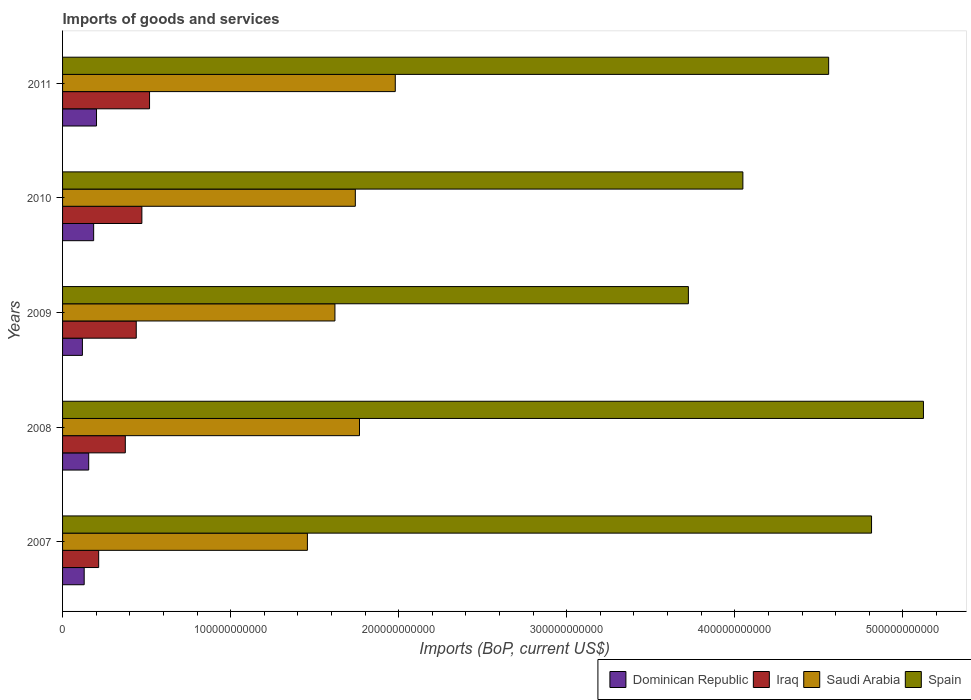How many different coloured bars are there?
Offer a terse response. 4. Are the number of bars per tick equal to the number of legend labels?
Make the answer very short. Yes. Are the number of bars on each tick of the Y-axis equal?
Your answer should be compact. Yes. How many bars are there on the 3rd tick from the top?
Ensure brevity in your answer.  4. How many bars are there on the 4th tick from the bottom?
Provide a succinct answer. 4. What is the amount spent on imports in Iraq in 2011?
Offer a very short reply. 5.18e+1. Across all years, what is the maximum amount spent on imports in Iraq?
Offer a terse response. 5.18e+1. Across all years, what is the minimum amount spent on imports in Dominican Republic?
Give a very brief answer. 1.18e+1. In which year was the amount spent on imports in Dominican Republic maximum?
Keep it short and to the point. 2011. In which year was the amount spent on imports in Iraq minimum?
Provide a short and direct response. 2007. What is the total amount spent on imports in Saudi Arabia in the graph?
Offer a terse response. 8.57e+11. What is the difference between the amount spent on imports in Iraq in 2007 and that in 2009?
Make the answer very short. -2.24e+1. What is the difference between the amount spent on imports in Saudi Arabia in 2008 and the amount spent on imports in Dominican Republic in 2007?
Offer a very short reply. 1.64e+11. What is the average amount spent on imports in Dominican Republic per year?
Give a very brief answer. 1.58e+1. In the year 2009, what is the difference between the amount spent on imports in Iraq and amount spent on imports in Spain?
Your answer should be very brief. -3.29e+11. In how many years, is the amount spent on imports in Iraq greater than 160000000000 US$?
Offer a terse response. 0. What is the ratio of the amount spent on imports in Iraq in 2007 to that in 2010?
Make the answer very short. 0.46. Is the amount spent on imports in Saudi Arabia in 2010 less than that in 2011?
Your response must be concise. Yes. Is the difference between the amount spent on imports in Iraq in 2007 and 2009 greater than the difference between the amount spent on imports in Spain in 2007 and 2009?
Ensure brevity in your answer.  No. What is the difference between the highest and the second highest amount spent on imports in Saudi Arabia?
Keep it short and to the point. 2.13e+1. What is the difference between the highest and the lowest amount spent on imports in Saudi Arabia?
Your answer should be compact. 5.23e+1. Is the sum of the amount spent on imports in Saudi Arabia in 2007 and 2008 greater than the maximum amount spent on imports in Spain across all years?
Your answer should be very brief. No. Is it the case that in every year, the sum of the amount spent on imports in Dominican Republic and amount spent on imports in Iraq is greater than the sum of amount spent on imports in Spain and amount spent on imports in Saudi Arabia?
Offer a very short reply. No. What does the 3rd bar from the top in 2011 represents?
Ensure brevity in your answer.  Iraq. What does the 2nd bar from the bottom in 2009 represents?
Your answer should be very brief. Iraq. What is the difference between two consecutive major ticks on the X-axis?
Offer a terse response. 1.00e+11. Does the graph contain grids?
Give a very brief answer. No. How are the legend labels stacked?
Ensure brevity in your answer.  Horizontal. What is the title of the graph?
Give a very brief answer. Imports of goods and services. Does "Senegal" appear as one of the legend labels in the graph?
Provide a short and direct response. No. What is the label or title of the X-axis?
Offer a terse response. Imports (BoP, current US$). What is the label or title of the Y-axis?
Keep it short and to the point. Years. What is the Imports (BoP, current US$) of Dominican Republic in 2007?
Your answer should be very brief. 1.29e+1. What is the Imports (BoP, current US$) in Iraq in 2007?
Provide a succinct answer. 2.15e+1. What is the Imports (BoP, current US$) in Saudi Arabia in 2007?
Keep it short and to the point. 1.46e+11. What is the Imports (BoP, current US$) in Spain in 2007?
Your answer should be very brief. 4.81e+11. What is the Imports (BoP, current US$) in Dominican Republic in 2008?
Make the answer very short. 1.56e+1. What is the Imports (BoP, current US$) of Iraq in 2008?
Offer a terse response. 3.73e+1. What is the Imports (BoP, current US$) of Saudi Arabia in 2008?
Keep it short and to the point. 1.77e+11. What is the Imports (BoP, current US$) of Spain in 2008?
Provide a short and direct response. 5.12e+11. What is the Imports (BoP, current US$) in Dominican Republic in 2009?
Offer a very short reply. 1.18e+1. What is the Imports (BoP, current US$) in Iraq in 2009?
Keep it short and to the point. 4.38e+1. What is the Imports (BoP, current US$) in Saudi Arabia in 2009?
Give a very brief answer. 1.62e+11. What is the Imports (BoP, current US$) in Spain in 2009?
Your answer should be compact. 3.72e+11. What is the Imports (BoP, current US$) of Dominican Republic in 2010?
Your answer should be very brief. 1.85e+1. What is the Imports (BoP, current US$) in Iraq in 2010?
Keep it short and to the point. 4.72e+1. What is the Imports (BoP, current US$) in Saudi Arabia in 2010?
Your response must be concise. 1.74e+11. What is the Imports (BoP, current US$) of Spain in 2010?
Your answer should be compact. 4.05e+11. What is the Imports (BoP, current US$) in Dominican Republic in 2011?
Offer a terse response. 2.02e+1. What is the Imports (BoP, current US$) in Iraq in 2011?
Provide a succinct answer. 5.18e+1. What is the Imports (BoP, current US$) in Saudi Arabia in 2011?
Ensure brevity in your answer.  1.98e+11. What is the Imports (BoP, current US$) of Spain in 2011?
Provide a short and direct response. 4.56e+11. Across all years, what is the maximum Imports (BoP, current US$) of Dominican Republic?
Your answer should be compact. 2.02e+1. Across all years, what is the maximum Imports (BoP, current US$) of Iraq?
Your response must be concise. 5.18e+1. Across all years, what is the maximum Imports (BoP, current US$) of Saudi Arabia?
Your answer should be very brief. 1.98e+11. Across all years, what is the maximum Imports (BoP, current US$) in Spain?
Make the answer very short. 5.12e+11. Across all years, what is the minimum Imports (BoP, current US$) in Dominican Republic?
Make the answer very short. 1.18e+1. Across all years, what is the minimum Imports (BoP, current US$) in Iraq?
Your answer should be very brief. 2.15e+1. Across all years, what is the minimum Imports (BoP, current US$) of Saudi Arabia?
Give a very brief answer. 1.46e+11. Across all years, what is the minimum Imports (BoP, current US$) in Spain?
Ensure brevity in your answer.  3.72e+11. What is the total Imports (BoP, current US$) in Dominican Republic in the graph?
Provide a succinct answer. 7.89e+1. What is the total Imports (BoP, current US$) in Iraq in the graph?
Keep it short and to the point. 2.02e+11. What is the total Imports (BoP, current US$) in Saudi Arabia in the graph?
Your answer should be compact. 8.57e+11. What is the total Imports (BoP, current US$) in Spain in the graph?
Provide a short and direct response. 2.23e+12. What is the difference between the Imports (BoP, current US$) of Dominican Republic in 2007 and that in 2008?
Provide a succinct answer. -2.68e+09. What is the difference between the Imports (BoP, current US$) of Iraq in 2007 and that in 2008?
Provide a short and direct response. -1.58e+1. What is the difference between the Imports (BoP, current US$) in Saudi Arabia in 2007 and that in 2008?
Provide a short and direct response. -3.10e+1. What is the difference between the Imports (BoP, current US$) in Spain in 2007 and that in 2008?
Ensure brevity in your answer.  -3.09e+1. What is the difference between the Imports (BoP, current US$) in Dominican Republic in 2007 and that in 2009?
Offer a very short reply. 1.07e+09. What is the difference between the Imports (BoP, current US$) of Iraq in 2007 and that in 2009?
Offer a terse response. -2.24e+1. What is the difference between the Imports (BoP, current US$) in Saudi Arabia in 2007 and that in 2009?
Offer a terse response. -1.64e+1. What is the difference between the Imports (BoP, current US$) in Spain in 2007 and that in 2009?
Your answer should be compact. 1.09e+11. What is the difference between the Imports (BoP, current US$) of Dominican Republic in 2007 and that in 2010?
Your response must be concise. -5.63e+09. What is the difference between the Imports (BoP, current US$) in Iraq in 2007 and that in 2010?
Your response must be concise. -2.57e+1. What is the difference between the Imports (BoP, current US$) in Saudi Arabia in 2007 and that in 2010?
Your response must be concise. -2.85e+1. What is the difference between the Imports (BoP, current US$) of Spain in 2007 and that in 2010?
Ensure brevity in your answer.  7.66e+1. What is the difference between the Imports (BoP, current US$) in Dominican Republic in 2007 and that in 2011?
Your answer should be very brief. -7.33e+09. What is the difference between the Imports (BoP, current US$) in Iraq in 2007 and that in 2011?
Your answer should be compact. -3.03e+1. What is the difference between the Imports (BoP, current US$) of Saudi Arabia in 2007 and that in 2011?
Ensure brevity in your answer.  -5.23e+1. What is the difference between the Imports (BoP, current US$) of Spain in 2007 and that in 2011?
Provide a short and direct response. 2.55e+1. What is the difference between the Imports (BoP, current US$) in Dominican Republic in 2008 and that in 2009?
Your answer should be compact. 3.75e+09. What is the difference between the Imports (BoP, current US$) of Iraq in 2008 and that in 2009?
Your answer should be very brief. -6.51e+09. What is the difference between the Imports (BoP, current US$) of Saudi Arabia in 2008 and that in 2009?
Ensure brevity in your answer.  1.46e+1. What is the difference between the Imports (BoP, current US$) in Spain in 2008 and that in 2009?
Provide a short and direct response. 1.40e+11. What is the difference between the Imports (BoP, current US$) of Dominican Republic in 2008 and that in 2010?
Offer a terse response. -2.94e+09. What is the difference between the Imports (BoP, current US$) of Iraq in 2008 and that in 2010?
Offer a terse response. -9.86e+09. What is the difference between the Imports (BoP, current US$) in Saudi Arabia in 2008 and that in 2010?
Ensure brevity in your answer.  2.48e+09. What is the difference between the Imports (BoP, current US$) in Spain in 2008 and that in 2010?
Make the answer very short. 1.07e+11. What is the difference between the Imports (BoP, current US$) in Dominican Republic in 2008 and that in 2011?
Give a very brief answer. -4.65e+09. What is the difference between the Imports (BoP, current US$) of Iraq in 2008 and that in 2011?
Keep it short and to the point. -1.44e+1. What is the difference between the Imports (BoP, current US$) in Saudi Arabia in 2008 and that in 2011?
Provide a succinct answer. -2.13e+1. What is the difference between the Imports (BoP, current US$) of Spain in 2008 and that in 2011?
Your response must be concise. 5.64e+1. What is the difference between the Imports (BoP, current US$) of Dominican Republic in 2009 and that in 2010?
Your answer should be compact. -6.69e+09. What is the difference between the Imports (BoP, current US$) of Iraq in 2009 and that in 2010?
Offer a very short reply. -3.34e+09. What is the difference between the Imports (BoP, current US$) in Saudi Arabia in 2009 and that in 2010?
Offer a very short reply. -1.21e+1. What is the difference between the Imports (BoP, current US$) of Spain in 2009 and that in 2010?
Your response must be concise. -3.24e+1. What is the difference between the Imports (BoP, current US$) in Dominican Republic in 2009 and that in 2011?
Your response must be concise. -8.40e+09. What is the difference between the Imports (BoP, current US$) in Iraq in 2009 and that in 2011?
Keep it short and to the point. -7.91e+09. What is the difference between the Imports (BoP, current US$) of Saudi Arabia in 2009 and that in 2011?
Provide a short and direct response. -3.59e+1. What is the difference between the Imports (BoP, current US$) of Spain in 2009 and that in 2011?
Make the answer very short. -8.35e+1. What is the difference between the Imports (BoP, current US$) in Dominican Republic in 2010 and that in 2011?
Offer a very short reply. -1.70e+09. What is the difference between the Imports (BoP, current US$) in Iraq in 2010 and that in 2011?
Ensure brevity in your answer.  -4.57e+09. What is the difference between the Imports (BoP, current US$) of Saudi Arabia in 2010 and that in 2011?
Your response must be concise. -2.38e+1. What is the difference between the Imports (BoP, current US$) of Spain in 2010 and that in 2011?
Offer a terse response. -5.10e+1. What is the difference between the Imports (BoP, current US$) in Dominican Republic in 2007 and the Imports (BoP, current US$) in Iraq in 2008?
Keep it short and to the point. -2.45e+1. What is the difference between the Imports (BoP, current US$) of Dominican Republic in 2007 and the Imports (BoP, current US$) of Saudi Arabia in 2008?
Ensure brevity in your answer.  -1.64e+11. What is the difference between the Imports (BoP, current US$) of Dominican Republic in 2007 and the Imports (BoP, current US$) of Spain in 2008?
Provide a short and direct response. -4.99e+11. What is the difference between the Imports (BoP, current US$) of Iraq in 2007 and the Imports (BoP, current US$) of Saudi Arabia in 2008?
Offer a very short reply. -1.55e+11. What is the difference between the Imports (BoP, current US$) in Iraq in 2007 and the Imports (BoP, current US$) in Spain in 2008?
Your answer should be compact. -4.91e+11. What is the difference between the Imports (BoP, current US$) in Saudi Arabia in 2007 and the Imports (BoP, current US$) in Spain in 2008?
Your response must be concise. -3.67e+11. What is the difference between the Imports (BoP, current US$) in Dominican Republic in 2007 and the Imports (BoP, current US$) in Iraq in 2009?
Keep it short and to the point. -3.10e+1. What is the difference between the Imports (BoP, current US$) in Dominican Republic in 2007 and the Imports (BoP, current US$) in Saudi Arabia in 2009?
Provide a short and direct response. -1.49e+11. What is the difference between the Imports (BoP, current US$) in Dominican Republic in 2007 and the Imports (BoP, current US$) in Spain in 2009?
Keep it short and to the point. -3.60e+11. What is the difference between the Imports (BoP, current US$) in Iraq in 2007 and the Imports (BoP, current US$) in Saudi Arabia in 2009?
Provide a short and direct response. -1.41e+11. What is the difference between the Imports (BoP, current US$) of Iraq in 2007 and the Imports (BoP, current US$) of Spain in 2009?
Ensure brevity in your answer.  -3.51e+11. What is the difference between the Imports (BoP, current US$) in Saudi Arabia in 2007 and the Imports (BoP, current US$) in Spain in 2009?
Your answer should be compact. -2.27e+11. What is the difference between the Imports (BoP, current US$) of Dominican Republic in 2007 and the Imports (BoP, current US$) of Iraq in 2010?
Keep it short and to the point. -3.43e+1. What is the difference between the Imports (BoP, current US$) in Dominican Republic in 2007 and the Imports (BoP, current US$) in Saudi Arabia in 2010?
Provide a succinct answer. -1.61e+11. What is the difference between the Imports (BoP, current US$) in Dominican Republic in 2007 and the Imports (BoP, current US$) in Spain in 2010?
Your answer should be compact. -3.92e+11. What is the difference between the Imports (BoP, current US$) in Iraq in 2007 and the Imports (BoP, current US$) in Saudi Arabia in 2010?
Your answer should be compact. -1.53e+11. What is the difference between the Imports (BoP, current US$) in Iraq in 2007 and the Imports (BoP, current US$) in Spain in 2010?
Your answer should be very brief. -3.83e+11. What is the difference between the Imports (BoP, current US$) of Saudi Arabia in 2007 and the Imports (BoP, current US$) of Spain in 2010?
Offer a terse response. -2.59e+11. What is the difference between the Imports (BoP, current US$) in Dominican Republic in 2007 and the Imports (BoP, current US$) in Iraq in 2011?
Offer a very short reply. -3.89e+1. What is the difference between the Imports (BoP, current US$) in Dominican Republic in 2007 and the Imports (BoP, current US$) in Saudi Arabia in 2011?
Ensure brevity in your answer.  -1.85e+11. What is the difference between the Imports (BoP, current US$) in Dominican Republic in 2007 and the Imports (BoP, current US$) in Spain in 2011?
Provide a short and direct response. -4.43e+11. What is the difference between the Imports (BoP, current US$) in Iraq in 2007 and the Imports (BoP, current US$) in Saudi Arabia in 2011?
Your answer should be compact. -1.76e+11. What is the difference between the Imports (BoP, current US$) in Iraq in 2007 and the Imports (BoP, current US$) in Spain in 2011?
Keep it short and to the point. -4.34e+11. What is the difference between the Imports (BoP, current US$) of Saudi Arabia in 2007 and the Imports (BoP, current US$) of Spain in 2011?
Provide a succinct answer. -3.10e+11. What is the difference between the Imports (BoP, current US$) of Dominican Republic in 2008 and the Imports (BoP, current US$) of Iraq in 2009?
Your response must be concise. -2.83e+1. What is the difference between the Imports (BoP, current US$) of Dominican Republic in 2008 and the Imports (BoP, current US$) of Saudi Arabia in 2009?
Provide a short and direct response. -1.47e+11. What is the difference between the Imports (BoP, current US$) of Dominican Republic in 2008 and the Imports (BoP, current US$) of Spain in 2009?
Your answer should be compact. -3.57e+11. What is the difference between the Imports (BoP, current US$) in Iraq in 2008 and the Imports (BoP, current US$) in Saudi Arabia in 2009?
Offer a very short reply. -1.25e+11. What is the difference between the Imports (BoP, current US$) in Iraq in 2008 and the Imports (BoP, current US$) in Spain in 2009?
Provide a succinct answer. -3.35e+11. What is the difference between the Imports (BoP, current US$) of Saudi Arabia in 2008 and the Imports (BoP, current US$) of Spain in 2009?
Your answer should be compact. -1.96e+11. What is the difference between the Imports (BoP, current US$) in Dominican Republic in 2008 and the Imports (BoP, current US$) in Iraq in 2010?
Your answer should be very brief. -3.16e+1. What is the difference between the Imports (BoP, current US$) in Dominican Republic in 2008 and the Imports (BoP, current US$) in Saudi Arabia in 2010?
Ensure brevity in your answer.  -1.59e+11. What is the difference between the Imports (BoP, current US$) in Dominican Republic in 2008 and the Imports (BoP, current US$) in Spain in 2010?
Give a very brief answer. -3.89e+11. What is the difference between the Imports (BoP, current US$) in Iraq in 2008 and the Imports (BoP, current US$) in Saudi Arabia in 2010?
Make the answer very short. -1.37e+11. What is the difference between the Imports (BoP, current US$) in Iraq in 2008 and the Imports (BoP, current US$) in Spain in 2010?
Give a very brief answer. -3.67e+11. What is the difference between the Imports (BoP, current US$) of Saudi Arabia in 2008 and the Imports (BoP, current US$) of Spain in 2010?
Your answer should be compact. -2.28e+11. What is the difference between the Imports (BoP, current US$) of Dominican Republic in 2008 and the Imports (BoP, current US$) of Iraq in 2011?
Make the answer very short. -3.62e+1. What is the difference between the Imports (BoP, current US$) in Dominican Republic in 2008 and the Imports (BoP, current US$) in Saudi Arabia in 2011?
Provide a succinct answer. -1.82e+11. What is the difference between the Imports (BoP, current US$) in Dominican Republic in 2008 and the Imports (BoP, current US$) in Spain in 2011?
Your response must be concise. -4.40e+11. What is the difference between the Imports (BoP, current US$) in Iraq in 2008 and the Imports (BoP, current US$) in Saudi Arabia in 2011?
Provide a succinct answer. -1.61e+11. What is the difference between the Imports (BoP, current US$) of Iraq in 2008 and the Imports (BoP, current US$) of Spain in 2011?
Keep it short and to the point. -4.19e+11. What is the difference between the Imports (BoP, current US$) of Saudi Arabia in 2008 and the Imports (BoP, current US$) of Spain in 2011?
Keep it short and to the point. -2.79e+11. What is the difference between the Imports (BoP, current US$) in Dominican Republic in 2009 and the Imports (BoP, current US$) in Iraq in 2010?
Your response must be concise. -3.54e+1. What is the difference between the Imports (BoP, current US$) in Dominican Republic in 2009 and the Imports (BoP, current US$) in Saudi Arabia in 2010?
Make the answer very short. -1.62e+11. What is the difference between the Imports (BoP, current US$) of Dominican Republic in 2009 and the Imports (BoP, current US$) of Spain in 2010?
Ensure brevity in your answer.  -3.93e+11. What is the difference between the Imports (BoP, current US$) of Iraq in 2009 and the Imports (BoP, current US$) of Saudi Arabia in 2010?
Give a very brief answer. -1.30e+11. What is the difference between the Imports (BoP, current US$) of Iraq in 2009 and the Imports (BoP, current US$) of Spain in 2010?
Your answer should be very brief. -3.61e+11. What is the difference between the Imports (BoP, current US$) in Saudi Arabia in 2009 and the Imports (BoP, current US$) in Spain in 2010?
Provide a succinct answer. -2.43e+11. What is the difference between the Imports (BoP, current US$) in Dominican Republic in 2009 and the Imports (BoP, current US$) in Iraq in 2011?
Offer a terse response. -4.00e+1. What is the difference between the Imports (BoP, current US$) of Dominican Republic in 2009 and the Imports (BoP, current US$) of Saudi Arabia in 2011?
Make the answer very short. -1.86e+11. What is the difference between the Imports (BoP, current US$) of Dominican Republic in 2009 and the Imports (BoP, current US$) of Spain in 2011?
Provide a succinct answer. -4.44e+11. What is the difference between the Imports (BoP, current US$) of Iraq in 2009 and the Imports (BoP, current US$) of Saudi Arabia in 2011?
Provide a succinct answer. -1.54e+11. What is the difference between the Imports (BoP, current US$) of Iraq in 2009 and the Imports (BoP, current US$) of Spain in 2011?
Give a very brief answer. -4.12e+11. What is the difference between the Imports (BoP, current US$) of Saudi Arabia in 2009 and the Imports (BoP, current US$) of Spain in 2011?
Your answer should be very brief. -2.94e+11. What is the difference between the Imports (BoP, current US$) in Dominican Republic in 2010 and the Imports (BoP, current US$) in Iraq in 2011?
Your answer should be very brief. -3.33e+1. What is the difference between the Imports (BoP, current US$) in Dominican Republic in 2010 and the Imports (BoP, current US$) in Saudi Arabia in 2011?
Provide a short and direct response. -1.79e+11. What is the difference between the Imports (BoP, current US$) of Dominican Republic in 2010 and the Imports (BoP, current US$) of Spain in 2011?
Your response must be concise. -4.37e+11. What is the difference between the Imports (BoP, current US$) of Iraq in 2010 and the Imports (BoP, current US$) of Saudi Arabia in 2011?
Provide a short and direct response. -1.51e+11. What is the difference between the Imports (BoP, current US$) in Iraq in 2010 and the Imports (BoP, current US$) in Spain in 2011?
Your response must be concise. -4.09e+11. What is the difference between the Imports (BoP, current US$) in Saudi Arabia in 2010 and the Imports (BoP, current US$) in Spain in 2011?
Make the answer very short. -2.82e+11. What is the average Imports (BoP, current US$) of Dominican Republic per year?
Offer a terse response. 1.58e+1. What is the average Imports (BoP, current US$) in Iraq per year?
Keep it short and to the point. 4.03e+1. What is the average Imports (BoP, current US$) in Saudi Arabia per year?
Offer a very short reply. 1.71e+11. What is the average Imports (BoP, current US$) in Spain per year?
Keep it short and to the point. 4.45e+11. In the year 2007, what is the difference between the Imports (BoP, current US$) in Dominican Republic and Imports (BoP, current US$) in Iraq?
Your answer should be very brief. -8.62e+09. In the year 2007, what is the difference between the Imports (BoP, current US$) of Dominican Republic and Imports (BoP, current US$) of Saudi Arabia?
Give a very brief answer. -1.33e+11. In the year 2007, what is the difference between the Imports (BoP, current US$) in Dominican Republic and Imports (BoP, current US$) in Spain?
Offer a very short reply. -4.68e+11. In the year 2007, what is the difference between the Imports (BoP, current US$) in Iraq and Imports (BoP, current US$) in Saudi Arabia?
Your answer should be compact. -1.24e+11. In the year 2007, what is the difference between the Imports (BoP, current US$) of Iraq and Imports (BoP, current US$) of Spain?
Offer a very short reply. -4.60e+11. In the year 2007, what is the difference between the Imports (BoP, current US$) of Saudi Arabia and Imports (BoP, current US$) of Spain?
Provide a succinct answer. -3.36e+11. In the year 2008, what is the difference between the Imports (BoP, current US$) of Dominican Republic and Imports (BoP, current US$) of Iraq?
Your answer should be compact. -2.18e+1. In the year 2008, what is the difference between the Imports (BoP, current US$) in Dominican Republic and Imports (BoP, current US$) in Saudi Arabia?
Provide a succinct answer. -1.61e+11. In the year 2008, what is the difference between the Imports (BoP, current US$) of Dominican Republic and Imports (BoP, current US$) of Spain?
Keep it short and to the point. -4.97e+11. In the year 2008, what is the difference between the Imports (BoP, current US$) in Iraq and Imports (BoP, current US$) in Saudi Arabia?
Offer a terse response. -1.39e+11. In the year 2008, what is the difference between the Imports (BoP, current US$) in Iraq and Imports (BoP, current US$) in Spain?
Ensure brevity in your answer.  -4.75e+11. In the year 2008, what is the difference between the Imports (BoP, current US$) of Saudi Arabia and Imports (BoP, current US$) of Spain?
Ensure brevity in your answer.  -3.36e+11. In the year 2009, what is the difference between the Imports (BoP, current US$) in Dominican Republic and Imports (BoP, current US$) in Iraq?
Provide a succinct answer. -3.20e+1. In the year 2009, what is the difference between the Imports (BoP, current US$) in Dominican Republic and Imports (BoP, current US$) in Saudi Arabia?
Provide a succinct answer. -1.50e+11. In the year 2009, what is the difference between the Imports (BoP, current US$) in Dominican Republic and Imports (BoP, current US$) in Spain?
Keep it short and to the point. -3.61e+11. In the year 2009, what is the difference between the Imports (BoP, current US$) of Iraq and Imports (BoP, current US$) of Saudi Arabia?
Your response must be concise. -1.18e+11. In the year 2009, what is the difference between the Imports (BoP, current US$) in Iraq and Imports (BoP, current US$) in Spain?
Your response must be concise. -3.29e+11. In the year 2009, what is the difference between the Imports (BoP, current US$) of Saudi Arabia and Imports (BoP, current US$) of Spain?
Ensure brevity in your answer.  -2.10e+11. In the year 2010, what is the difference between the Imports (BoP, current US$) in Dominican Republic and Imports (BoP, current US$) in Iraq?
Provide a short and direct response. -2.87e+1. In the year 2010, what is the difference between the Imports (BoP, current US$) of Dominican Republic and Imports (BoP, current US$) of Saudi Arabia?
Provide a succinct answer. -1.56e+11. In the year 2010, what is the difference between the Imports (BoP, current US$) of Dominican Republic and Imports (BoP, current US$) of Spain?
Your response must be concise. -3.86e+11. In the year 2010, what is the difference between the Imports (BoP, current US$) in Iraq and Imports (BoP, current US$) in Saudi Arabia?
Give a very brief answer. -1.27e+11. In the year 2010, what is the difference between the Imports (BoP, current US$) in Iraq and Imports (BoP, current US$) in Spain?
Provide a short and direct response. -3.58e+11. In the year 2010, what is the difference between the Imports (BoP, current US$) in Saudi Arabia and Imports (BoP, current US$) in Spain?
Your answer should be very brief. -2.31e+11. In the year 2011, what is the difference between the Imports (BoP, current US$) of Dominican Republic and Imports (BoP, current US$) of Iraq?
Ensure brevity in your answer.  -3.16e+1. In the year 2011, what is the difference between the Imports (BoP, current US$) in Dominican Republic and Imports (BoP, current US$) in Saudi Arabia?
Make the answer very short. -1.78e+11. In the year 2011, what is the difference between the Imports (BoP, current US$) of Dominican Republic and Imports (BoP, current US$) of Spain?
Keep it short and to the point. -4.36e+11. In the year 2011, what is the difference between the Imports (BoP, current US$) of Iraq and Imports (BoP, current US$) of Saudi Arabia?
Your answer should be compact. -1.46e+11. In the year 2011, what is the difference between the Imports (BoP, current US$) in Iraq and Imports (BoP, current US$) in Spain?
Ensure brevity in your answer.  -4.04e+11. In the year 2011, what is the difference between the Imports (BoP, current US$) in Saudi Arabia and Imports (BoP, current US$) in Spain?
Offer a terse response. -2.58e+11. What is the ratio of the Imports (BoP, current US$) in Dominican Republic in 2007 to that in 2008?
Provide a succinct answer. 0.83. What is the ratio of the Imports (BoP, current US$) of Iraq in 2007 to that in 2008?
Your answer should be very brief. 0.58. What is the ratio of the Imports (BoP, current US$) in Saudi Arabia in 2007 to that in 2008?
Offer a very short reply. 0.82. What is the ratio of the Imports (BoP, current US$) in Spain in 2007 to that in 2008?
Provide a short and direct response. 0.94. What is the ratio of the Imports (BoP, current US$) of Dominican Republic in 2007 to that in 2009?
Offer a terse response. 1.09. What is the ratio of the Imports (BoP, current US$) of Iraq in 2007 to that in 2009?
Offer a terse response. 0.49. What is the ratio of the Imports (BoP, current US$) in Saudi Arabia in 2007 to that in 2009?
Ensure brevity in your answer.  0.9. What is the ratio of the Imports (BoP, current US$) in Spain in 2007 to that in 2009?
Provide a short and direct response. 1.29. What is the ratio of the Imports (BoP, current US$) in Dominican Republic in 2007 to that in 2010?
Your answer should be compact. 0.7. What is the ratio of the Imports (BoP, current US$) of Iraq in 2007 to that in 2010?
Your answer should be compact. 0.46. What is the ratio of the Imports (BoP, current US$) of Saudi Arabia in 2007 to that in 2010?
Keep it short and to the point. 0.84. What is the ratio of the Imports (BoP, current US$) in Spain in 2007 to that in 2010?
Give a very brief answer. 1.19. What is the ratio of the Imports (BoP, current US$) of Dominican Republic in 2007 to that in 2011?
Offer a terse response. 0.64. What is the ratio of the Imports (BoP, current US$) in Iraq in 2007 to that in 2011?
Offer a very short reply. 0.42. What is the ratio of the Imports (BoP, current US$) of Saudi Arabia in 2007 to that in 2011?
Your answer should be compact. 0.74. What is the ratio of the Imports (BoP, current US$) of Spain in 2007 to that in 2011?
Your answer should be very brief. 1.06. What is the ratio of the Imports (BoP, current US$) of Dominican Republic in 2008 to that in 2009?
Your answer should be very brief. 1.32. What is the ratio of the Imports (BoP, current US$) in Iraq in 2008 to that in 2009?
Offer a terse response. 0.85. What is the ratio of the Imports (BoP, current US$) in Saudi Arabia in 2008 to that in 2009?
Your answer should be very brief. 1.09. What is the ratio of the Imports (BoP, current US$) in Spain in 2008 to that in 2009?
Give a very brief answer. 1.38. What is the ratio of the Imports (BoP, current US$) of Dominican Republic in 2008 to that in 2010?
Keep it short and to the point. 0.84. What is the ratio of the Imports (BoP, current US$) in Iraq in 2008 to that in 2010?
Provide a short and direct response. 0.79. What is the ratio of the Imports (BoP, current US$) in Saudi Arabia in 2008 to that in 2010?
Offer a very short reply. 1.01. What is the ratio of the Imports (BoP, current US$) of Spain in 2008 to that in 2010?
Provide a succinct answer. 1.27. What is the ratio of the Imports (BoP, current US$) of Dominican Republic in 2008 to that in 2011?
Provide a short and direct response. 0.77. What is the ratio of the Imports (BoP, current US$) of Iraq in 2008 to that in 2011?
Ensure brevity in your answer.  0.72. What is the ratio of the Imports (BoP, current US$) of Saudi Arabia in 2008 to that in 2011?
Give a very brief answer. 0.89. What is the ratio of the Imports (BoP, current US$) in Spain in 2008 to that in 2011?
Offer a very short reply. 1.12. What is the ratio of the Imports (BoP, current US$) in Dominican Republic in 2009 to that in 2010?
Make the answer very short. 0.64. What is the ratio of the Imports (BoP, current US$) in Iraq in 2009 to that in 2010?
Offer a very short reply. 0.93. What is the ratio of the Imports (BoP, current US$) of Saudi Arabia in 2009 to that in 2010?
Give a very brief answer. 0.93. What is the ratio of the Imports (BoP, current US$) of Spain in 2009 to that in 2010?
Provide a succinct answer. 0.92. What is the ratio of the Imports (BoP, current US$) in Dominican Republic in 2009 to that in 2011?
Make the answer very short. 0.58. What is the ratio of the Imports (BoP, current US$) in Iraq in 2009 to that in 2011?
Offer a very short reply. 0.85. What is the ratio of the Imports (BoP, current US$) of Saudi Arabia in 2009 to that in 2011?
Provide a succinct answer. 0.82. What is the ratio of the Imports (BoP, current US$) of Spain in 2009 to that in 2011?
Offer a very short reply. 0.82. What is the ratio of the Imports (BoP, current US$) of Dominican Republic in 2010 to that in 2011?
Your answer should be very brief. 0.92. What is the ratio of the Imports (BoP, current US$) in Iraq in 2010 to that in 2011?
Provide a succinct answer. 0.91. What is the ratio of the Imports (BoP, current US$) in Saudi Arabia in 2010 to that in 2011?
Provide a succinct answer. 0.88. What is the ratio of the Imports (BoP, current US$) of Spain in 2010 to that in 2011?
Offer a very short reply. 0.89. What is the difference between the highest and the second highest Imports (BoP, current US$) in Dominican Republic?
Ensure brevity in your answer.  1.70e+09. What is the difference between the highest and the second highest Imports (BoP, current US$) in Iraq?
Offer a very short reply. 4.57e+09. What is the difference between the highest and the second highest Imports (BoP, current US$) in Saudi Arabia?
Provide a short and direct response. 2.13e+1. What is the difference between the highest and the second highest Imports (BoP, current US$) of Spain?
Keep it short and to the point. 3.09e+1. What is the difference between the highest and the lowest Imports (BoP, current US$) in Dominican Republic?
Offer a very short reply. 8.40e+09. What is the difference between the highest and the lowest Imports (BoP, current US$) in Iraq?
Provide a short and direct response. 3.03e+1. What is the difference between the highest and the lowest Imports (BoP, current US$) of Saudi Arabia?
Your response must be concise. 5.23e+1. What is the difference between the highest and the lowest Imports (BoP, current US$) in Spain?
Offer a very short reply. 1.40e+11. 